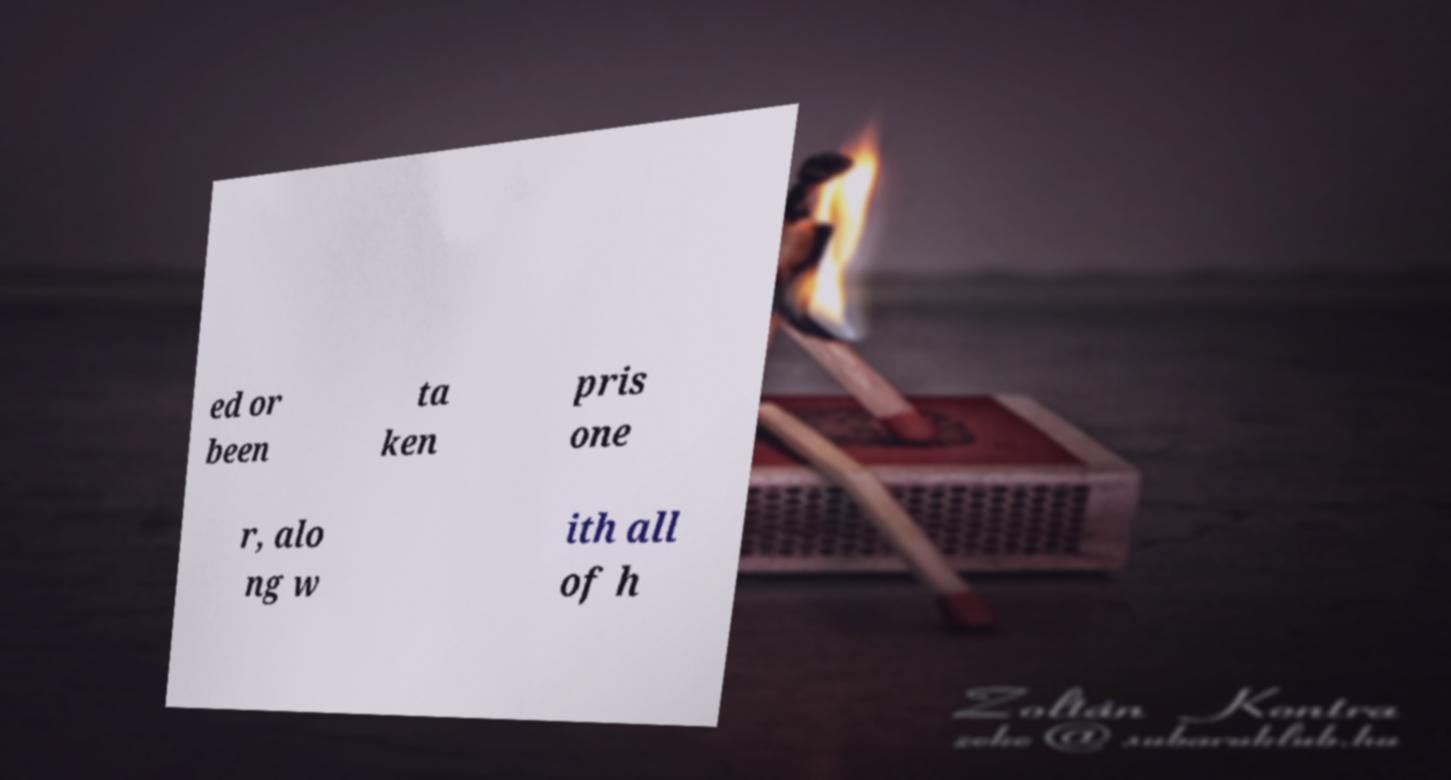Can you read and provide the text displayed in the image?This photo seems to have some interesting text. Can you extract and type it out for me? ed or been ta ken pris one r, alo ng w ith all of h 